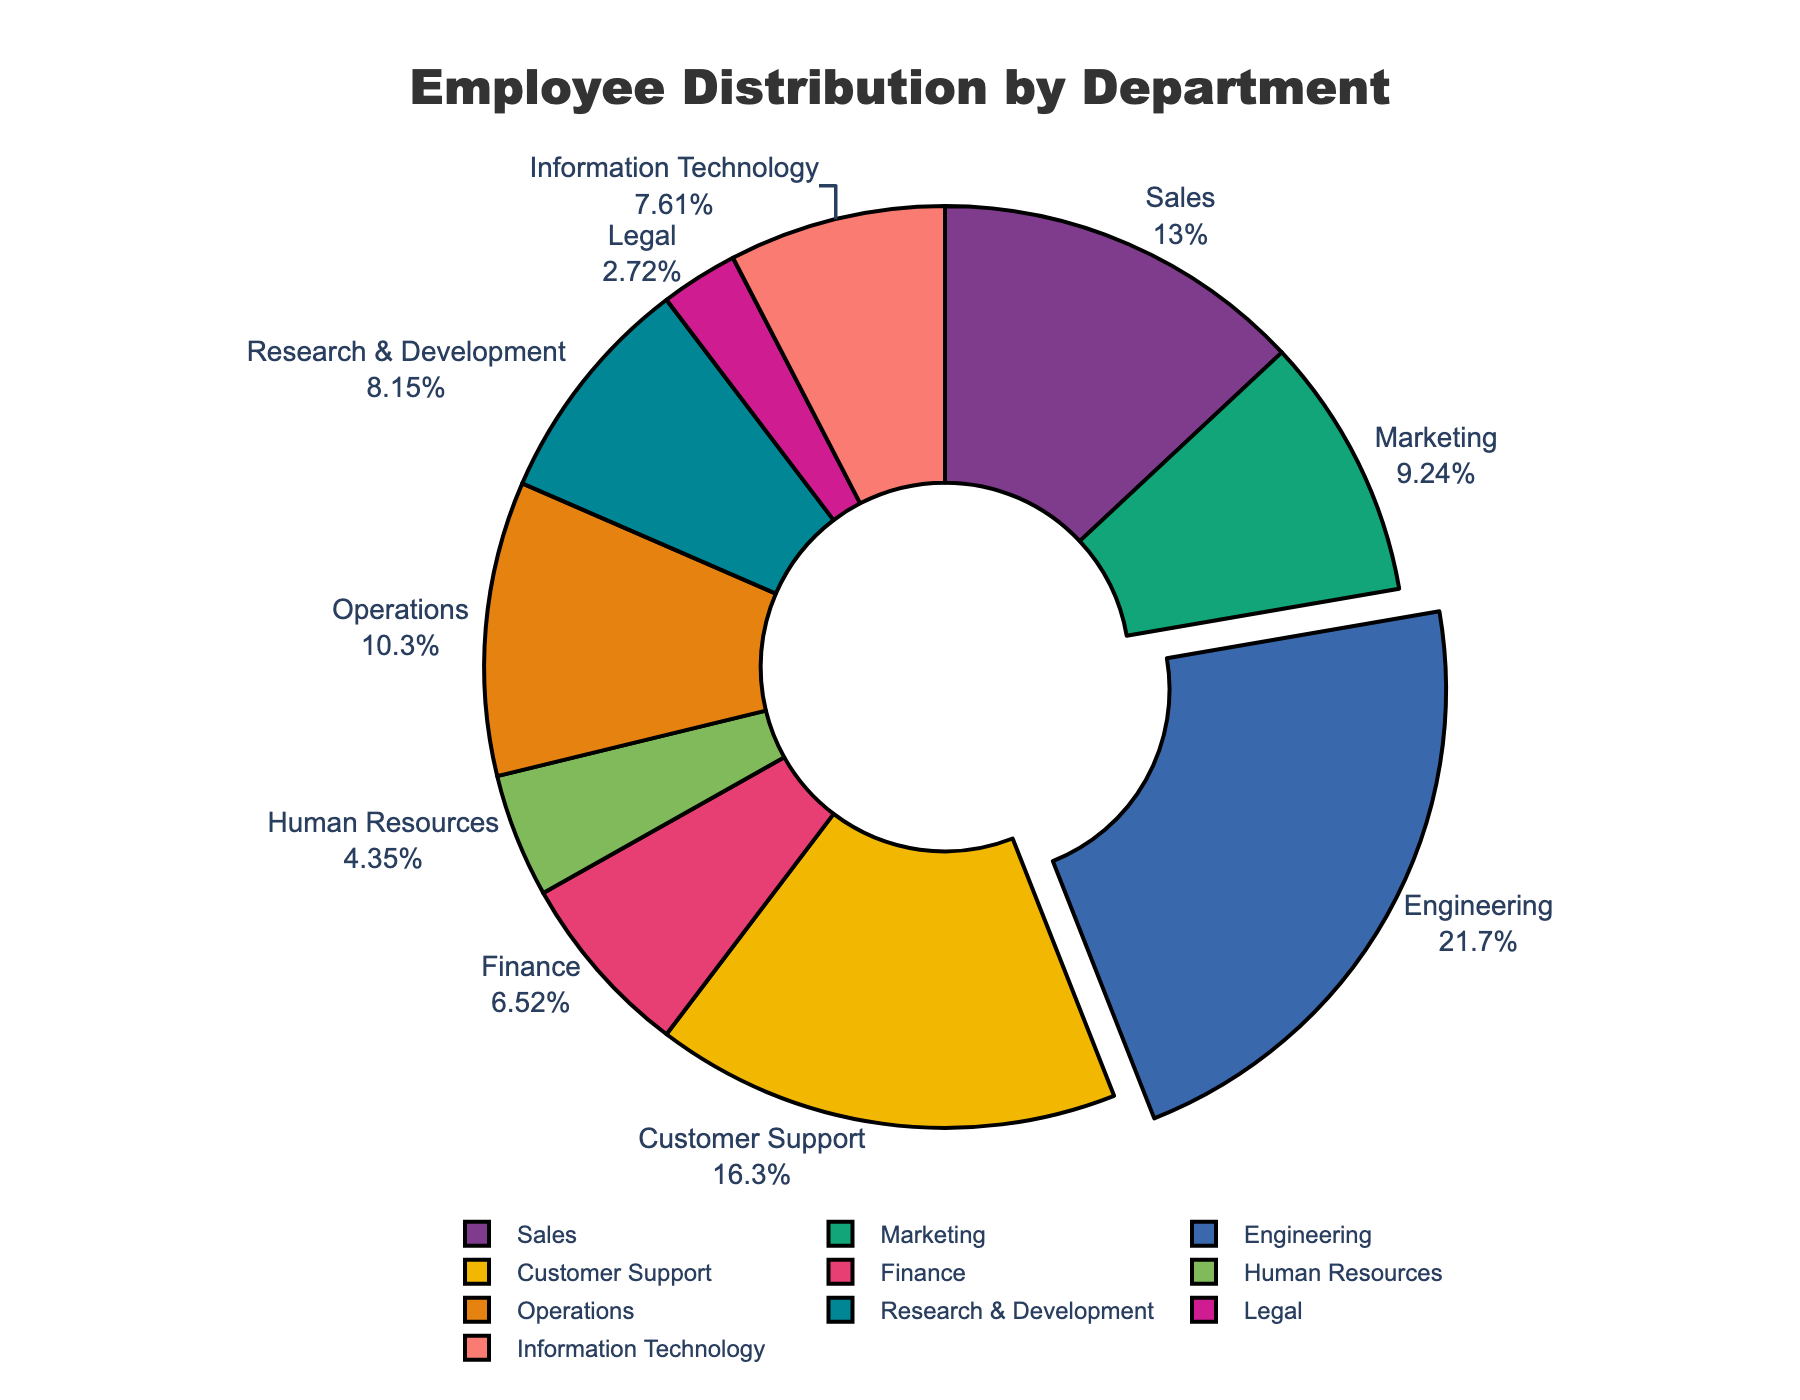What's the largest department in terms of employee numbers? The pie chart will indicate the size of each department by its slice size. The largest slice is the one that represents the Engineering department.
Answer: Engineering How many employees are in the Operations and Customer Support departments combined? Looking at the pie chart, Operations has 95 employees and Customer Support has 150 employees. Sum these two numbers: 95 + 150 = 245.
Answer: 245 Which department has more employees: Marketing or Information Technology? By comparing the sizes of the slices, Marketing has 85 employees while Information Technology has 70 employees. Therefore, Marketing has more employees.
Answer: Marketing What percentage of the total employees does the Sales department have? The pie chart shows both the count and the percentage for each department. Sales has 120 employees, which accounts for approximately 17.14% of the total (calculated as 120/700 ≈ 0.1714).
Answer: 17.14% What is the difference in the number of employees between the largest and smallest departments? The largest department is Engineering with 200 employees, and the smallest is Legal with 25 employees. The difference is 200 - 25 = 175 employees.
Answer: 175 Which department has the smallest number of employees? Observing the pie chart, the slice representing the Legal department is the smallest, which means it has the fewest employees.
Answer: Legal What is the average number of employees per department? There are 10 departments, and the total number of employees is 920. The average is calculated as 920/10 = 92.
Answer: 92 Are there more employees in Engineering and Customer Support combined than in all other departments combined? Engineering has 200 employees and Customer Support has 150, which totals 350. The total number of employees in all departments is 920. Therefore, 920 - 350 = 570. Since 570 > 350, the answer is no.
Answer: No Which department represents a bigger share of the employee count: Finance or Human Resources? The slices for Finance (60 employees) and Human Resources (40 employees) can be compared. Finance represents a bigger share since it has more employees.
Answer: Finance 